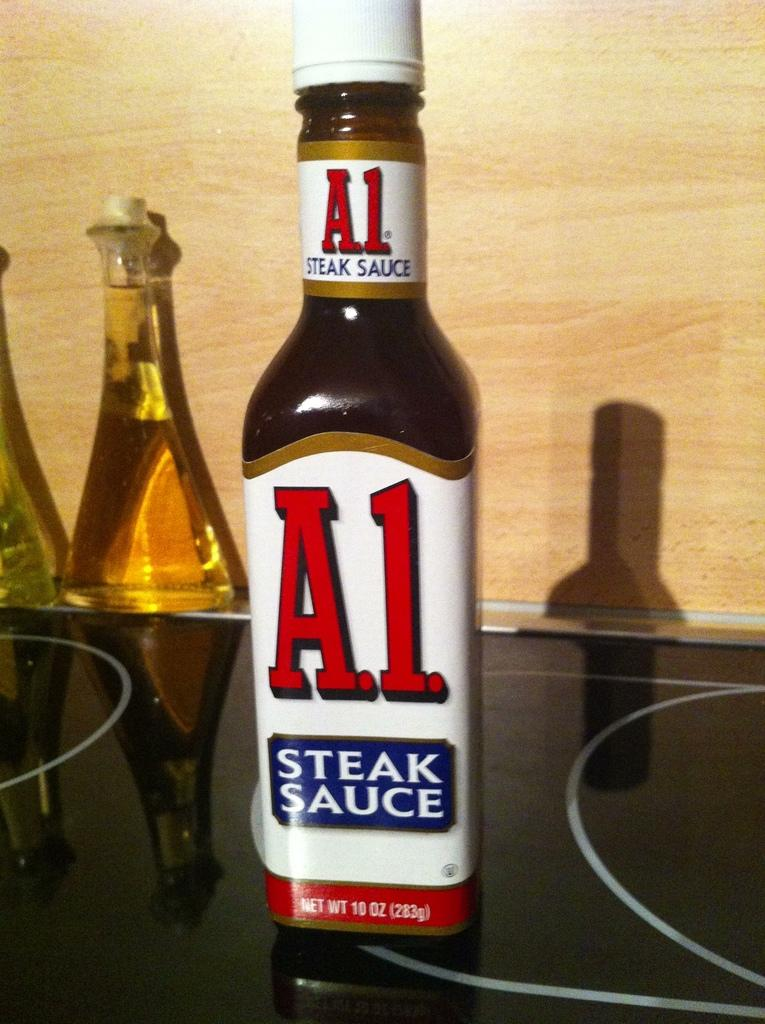Provide a one-sentence caption for the provided image. A bottle of A.1. steak sauce contains 10 oz of sauce. 